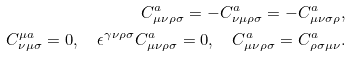<formula> <loc_0><loc_0><loc_500><loc_500>C ^ { a } _ { \mu \nu \rho \sigma } = - C ^ { a } _ { \nu \mu \rho \sigma } = - C ^ { a } _ { \mu \nu \sigma \rho } , \\ C ^ { \mu a } _ { \nu \mu \sigma } = 0 , \quad \epsilon ^ { \gamma \nu \rho \sigma } C ^ { a } _ { \mu \nu \rho \sigma } = 0 , \quad C ^ { a } _ { \mu \nu \rho \sigma } = C ^ { a } _ { \rho \sigma \mu \nu } .</formula> 